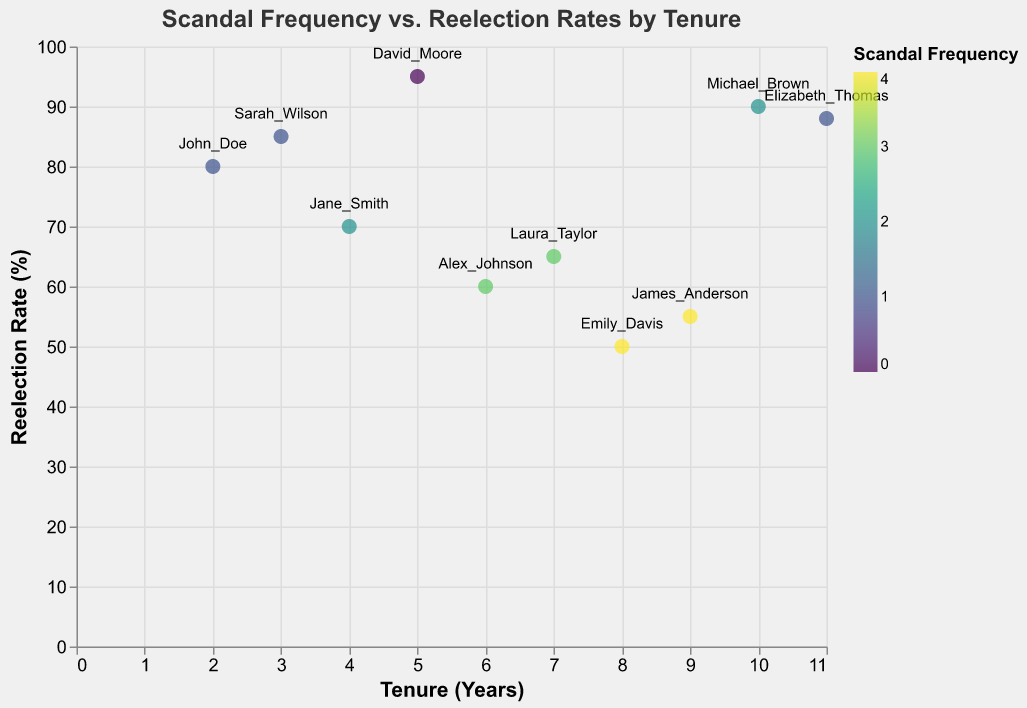What is the title of the figure? The title of a figure is typically located at the top and describes the content of the plot. In this case, the title is "Scandal Frequency vs. Reelection Rates by Tenure".
Answer: Scandal Frequency vs. Reelection Rates by Tenure What do the axes represent in this scatter plot? By observing the labels on the axes, we can determine what each axis represents. The x-axis is labeled "Tenure (Years)", indicating it shows the number of years of tenure. The y-axis is labeled "Reelection Rate (%)", showing the reelection rate as a percentage.
Answer: The x-axis represents Tenure (Years) and the y-axis represents Reelection Rate (%) How many politicians have a scandal frequency of 3? To find out how many politicians have a scandal frequency of 3, we look at the color legend and the data points whose color corresponds to a scandal frequency of 3. By counting these data points, we can determine the number.
Answer: 2 Which politician has the highest reelection rate and what is it? To find the politician with the highest reelection rate, we examine the y-axis and identify the highest data point. The tooltip or label indicates the politician's name and the exact rate.
Answer: David Moore with 95% Among politicians with a tenure of 6 years, what are the scandal frequency and reelection rate? Locate the data point where the x-axis (Tenure) is 6 years. The tooltip or label will provide additional details on the scandal frequency and reelection rate for this data point.
Answer: Scandal Frequency: 3, Reelection Rate: 60% Compare the reelection rates of politicians with a scandal frequency of 4. Who has the higher rate? Identify the data points with a scandal frequency of 4 (based on color). Compare their y-axis values (reelection rates) to determine who has the higher rate.
Answer: Emily Davis has a higher rate of 50%, compared to James Anderson with 55% Which politician has the lowest reelection rate and what is the scandal frequency? Identify the lowest data point on the y-axis (reelection rate). The tooltip or label will indicate the politician's name and the scandal frequency associated with this point.
Answer: Emily Davis with a scandal frequency of 4 What is the average reelection rate of politicians with a tenure of 8 or more years? Identify all data points where the x-axis value (Tenure) is 8 or more years. Sum the reelection rates (y-axis values) for these points and divide by the number of points to find the average. Detailed Steps: 1) Identify points: Emily Davis (50), Michael Brown (90), James Anderson (55), Elizabeth Thomas (88). 2) Sum of reelection rates: 50 + 90 + 55 + 88 = 283. 3) Number of points: 4. 4) Average = 283 / 4 = 70.75
Answer: 70.75% Is there a correlation between tenure and reelection rate among the politicians? Observe the general trend of the data points from left to right. If the plot shows a clear increase or decrease in reelection rate with tenure, there may be a correlation. Based on the scatter plot, we observe that as tenure increases, reelection rates tend to decrease.
Answer: Negative correlation Which politician with a scandal frequency of 2 has the highest reelection rate and what is the rate? Identify the data points with a scandal frequency of 2 using the color legend. Among these points, find the one with the highest y-axis value (reelection rate).
Answer: Michael Brown with 90% 